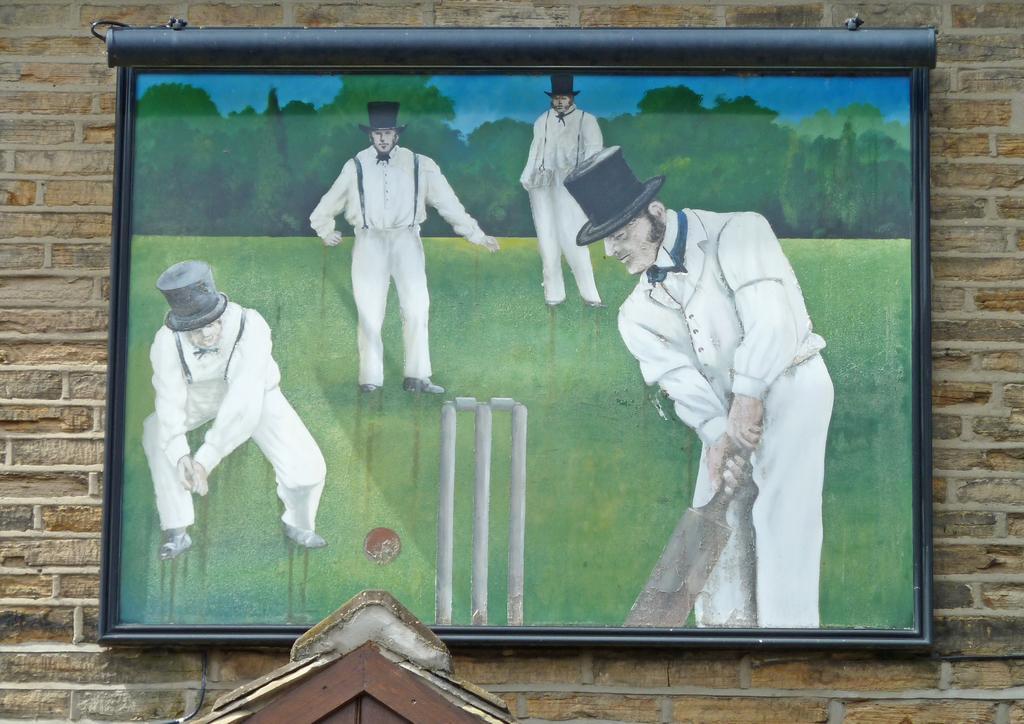How would you summarize this image in a sentence or two? There is a frame on the wall. Here we can see painting of four persons playing on the ground. There is a ball, wicket, trees, and sky. 